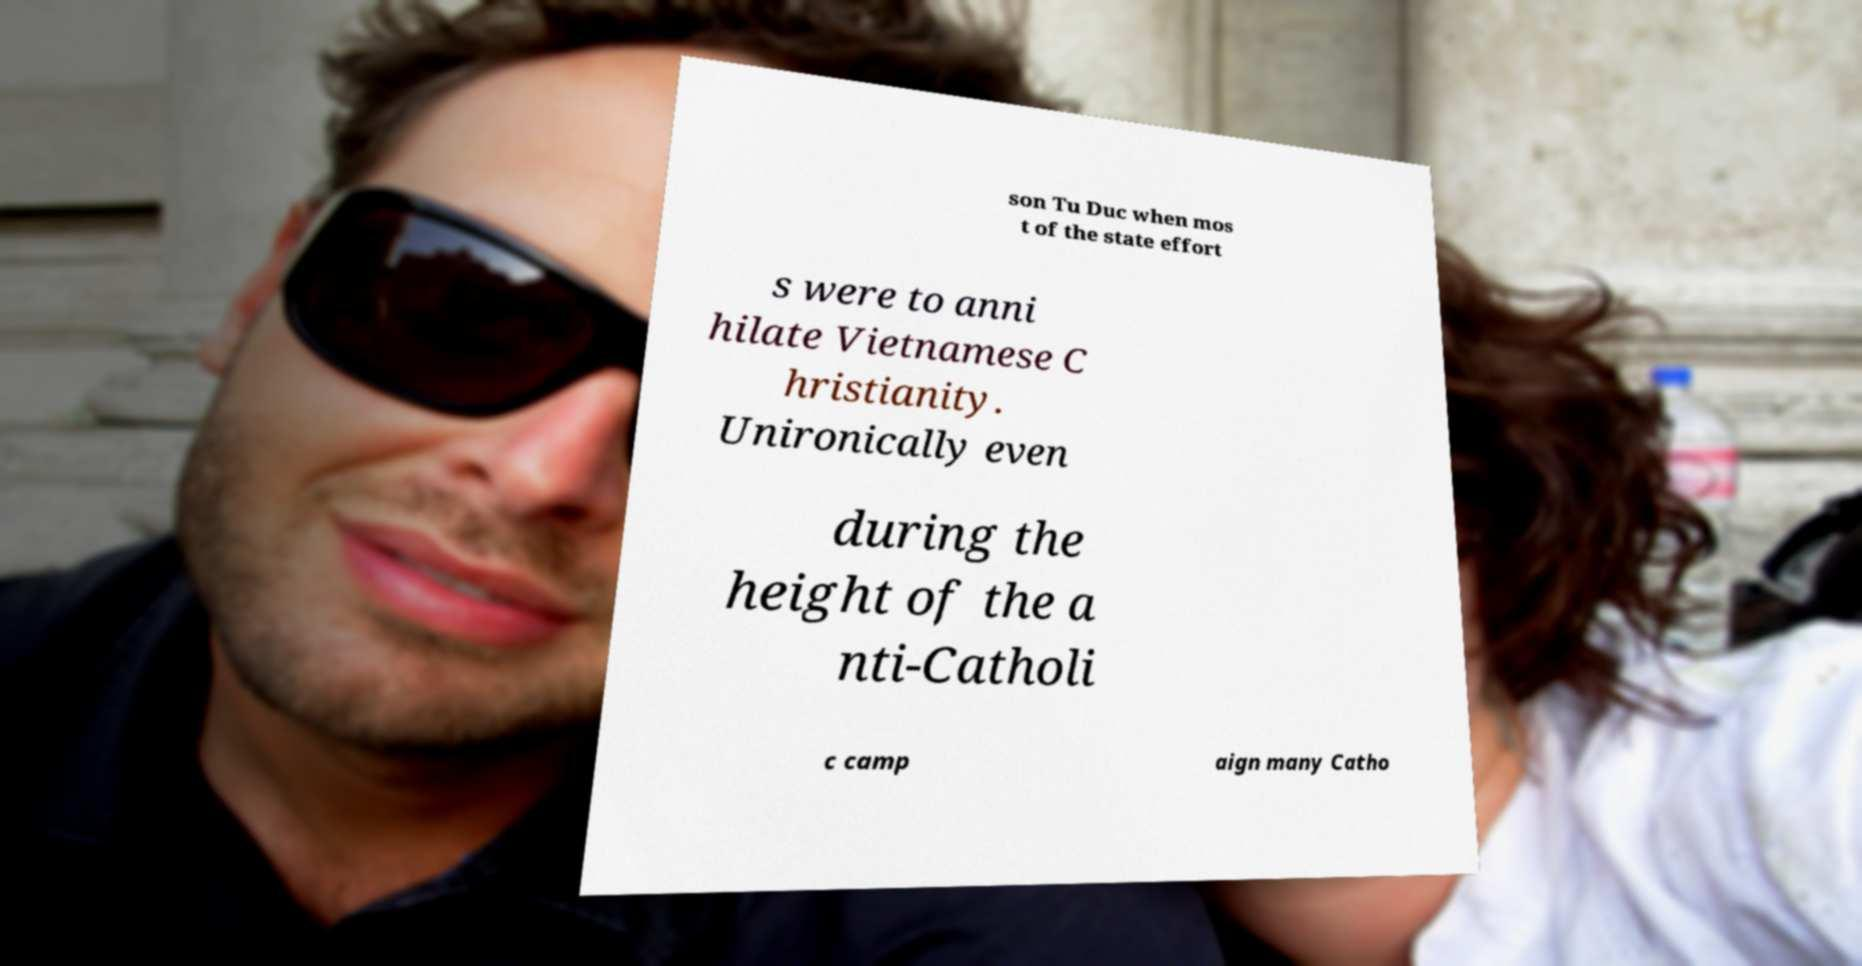I need the written content from this picture converted into text. Can you do that? son Tu Duc when mos t of the state effort s were to anni hilate Vietnamese C hristianity. Unironically even during the height of the a nti-Catholi c camp aign many Catho 